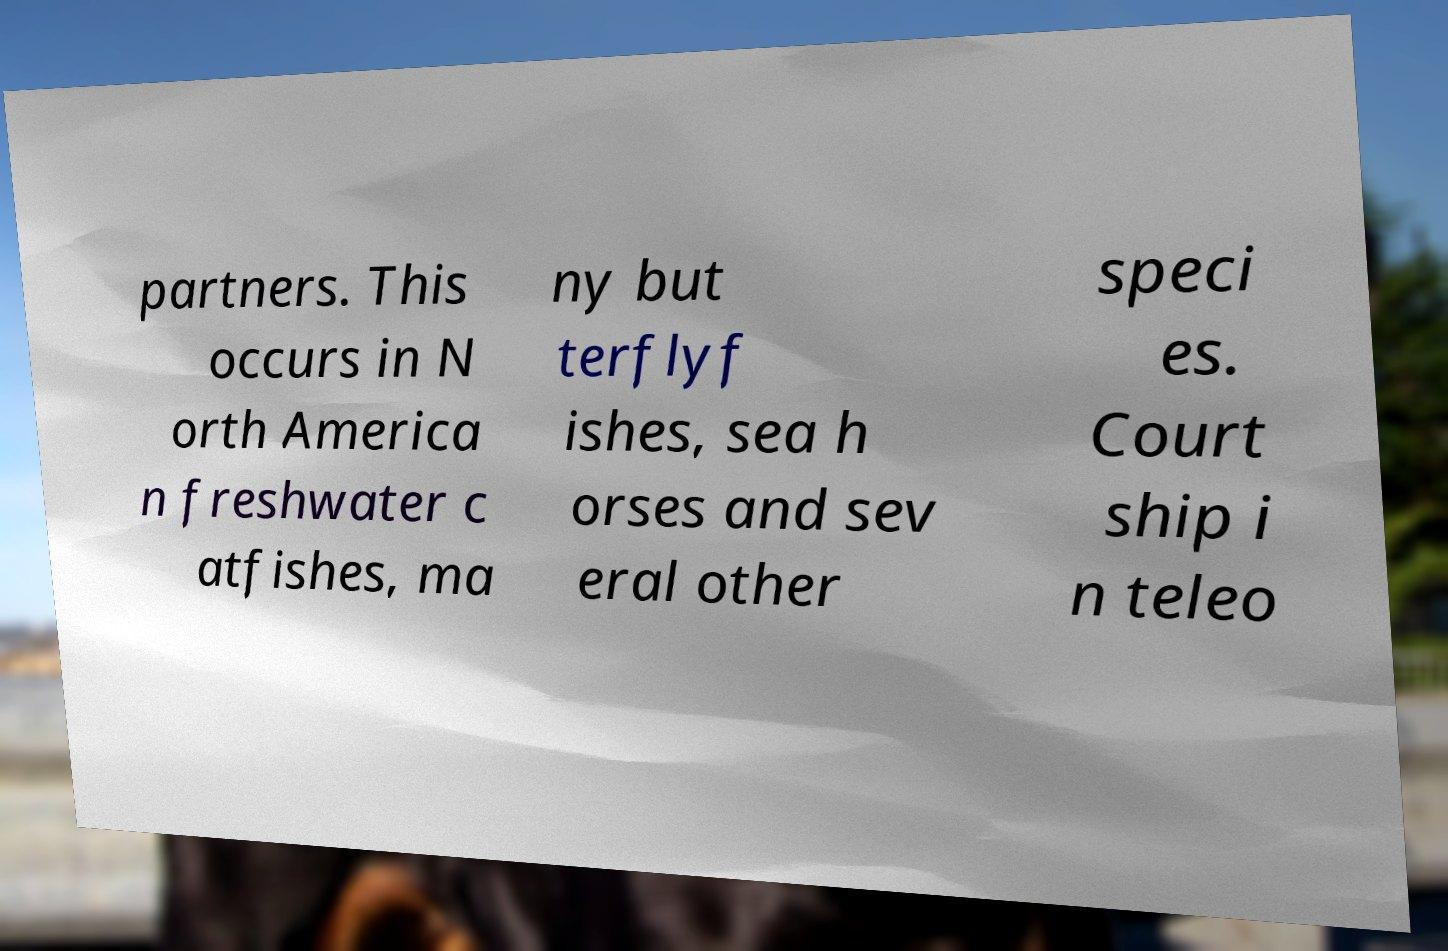What messages or text are displayed in this image? I need them in a readable, typed format. partners. This occurs in N orth America n freshwater c atfishes, ma ny but terflyf ishes, sea h orses and sev eral other speci es. Court ship i n teleo 